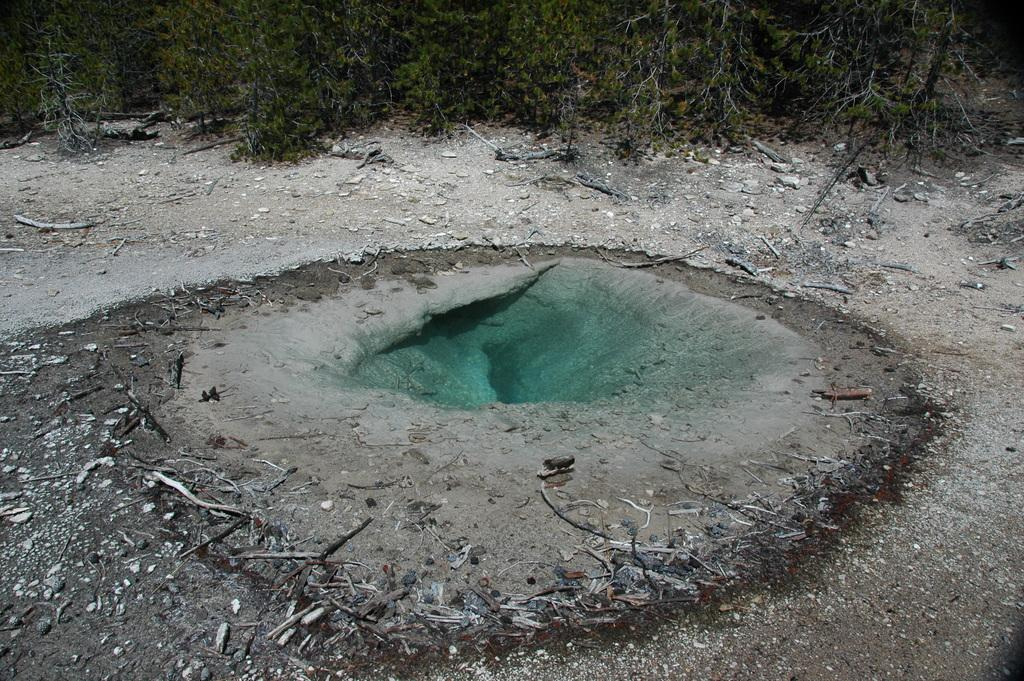Where was the image taken? The image was clicked outside. What type of terrain is visible in the image? There is sand on the ground in the image. What else can be seen on the ground in the image? Dried stems are present on the ground in the image. What color dominates the middle part of the image? The middle part of the image is green in color. What can be seen in the background of the image? There are trees in the background of the image. How does the school turn into a dust storm in the image? There is no school or dust storm present in the image. What type of dust can be seen on the ground in the image? There is no dust visible on the ground in the image; it features sand and dried stems. 